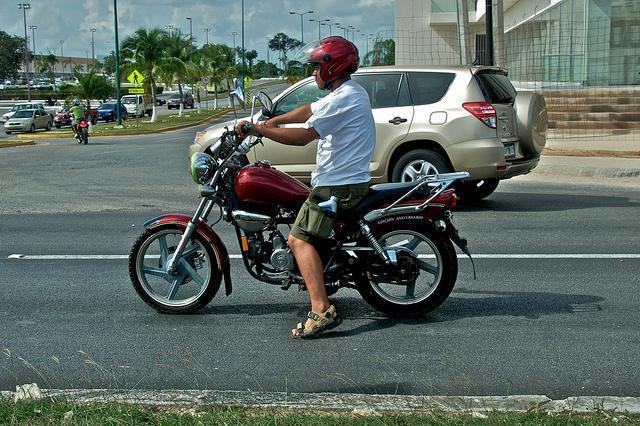How many people are in the picture?
Give a very brief answer. 1. 